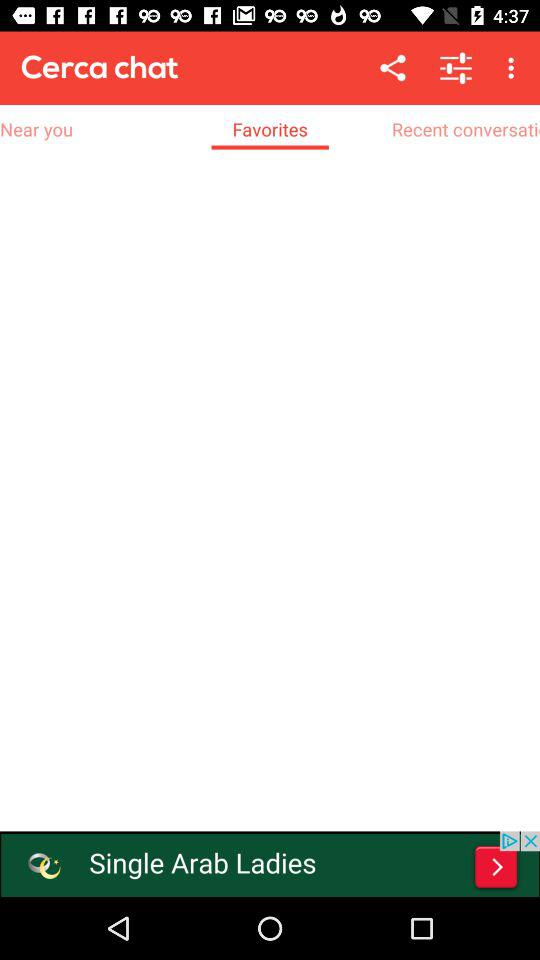Which tab am I using? You are using favorites. 